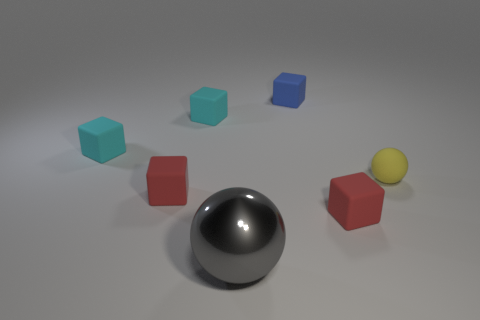Is there any other thing that has the same material as the gray object?
Provide a short and direct response. No. There is a yellow rubber ball; is its size the same as the red matte object on the right side of the large gray metallic ball?
Provide a succinct answer. Yes. What number of green things are blocks or spheres?
Provide a short and direct response. 0. How many cyan matte spheres are there?
Your response must be concise. 0. What is the size of the sphere on the left side of the matte ball?
Make the answer very short. Large. Do the gray sphere and the blue matte thing have the same size?
Your response must be concise. No. What number of objects are small things or matte things to the left of the yellow matte object?
Offer a terse response. 6. What is the large gray object made of?
Offer a very short reply. Metal. Are there any other things of the same color as the tiny sphere?
Your response must be concise. No. Do the small yellow object and the large gray metal object have the same shape?
Your answer should be compact. Yes. 